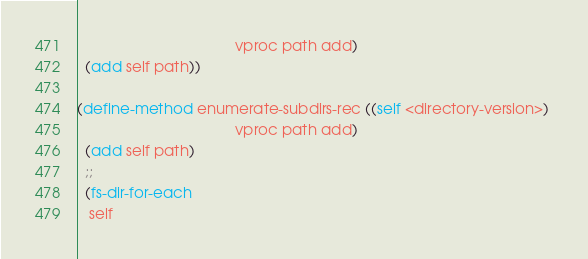<code> <loc_0><loc_0><loc_500><loc_500><_Scheme_>                                      vproc path add)
  (add self path))
                                      
(define-method enumerate-subdirs-rec ((self <directory-version>) 
                                      vproc path add)
  (add self path)
  ;;
  (fs-dir-for-each
   self</code> 